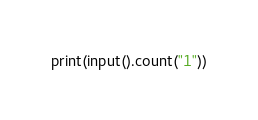Convert code to text. <code><loc_0><loc_0><loc_500><loc_500><_Python_>print(input().count("1"))
</code> 